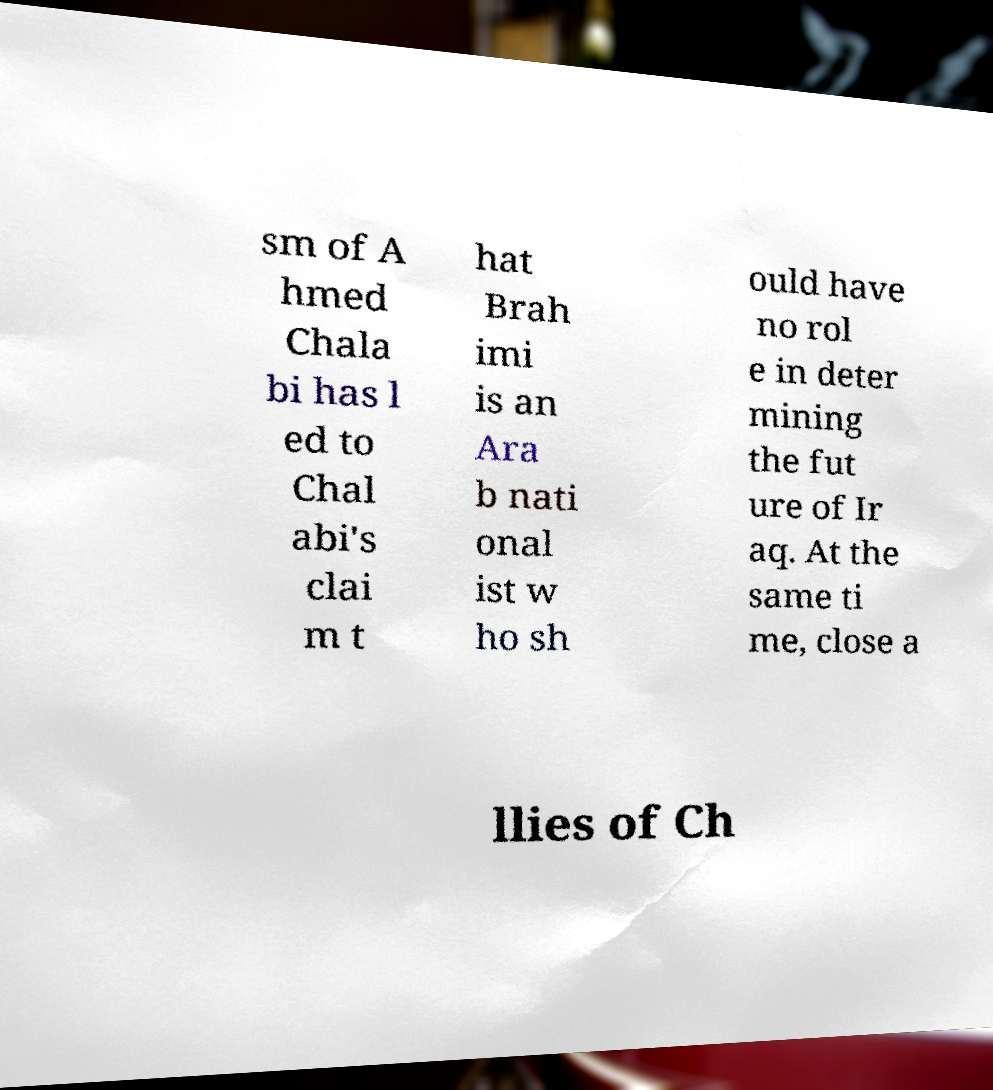Please identify and transcribe the text found in this image. sm of A hmed Chala bi has l ed to Chal abi's clai m t hat Brah imi is an Ara b nati onal ist w ho sh ould have no rol e in deter mining the fut ure of Ir aq. At the same ti me, close a llies of Ch 